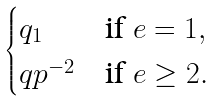Convert formula to latex. <formula><loc_0><loc_0><loc_500><loc_500>\begin{cases} q _ { 1 } & \text {if } e = 1 , \\ q p ^ { - 2 } & \text {if } e \geq 2 . \end{cases}</formula> 